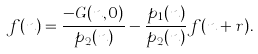<formula> <loc_0><loc_0><loc_500><loc_500>f ( n ) = \frac { - G ( n , 0 ) } { p _ { 2 } ( n ) } - \frac { p _ { 1 } ( n ) } { p _ { 2 } ( n ) } f ( n + r ) .</formula> 